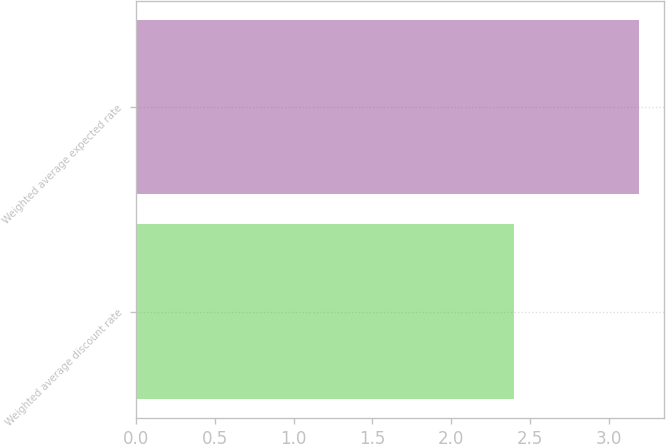Convert chart to OTSL. <chart><loc_0><loc_0><loc_500><loc_500><bar_chart><fcel>Weighted average discount rate<fcel>Weighted average expected rate<nl><fcel>2.4<fcel>3.19<nl></chart> 